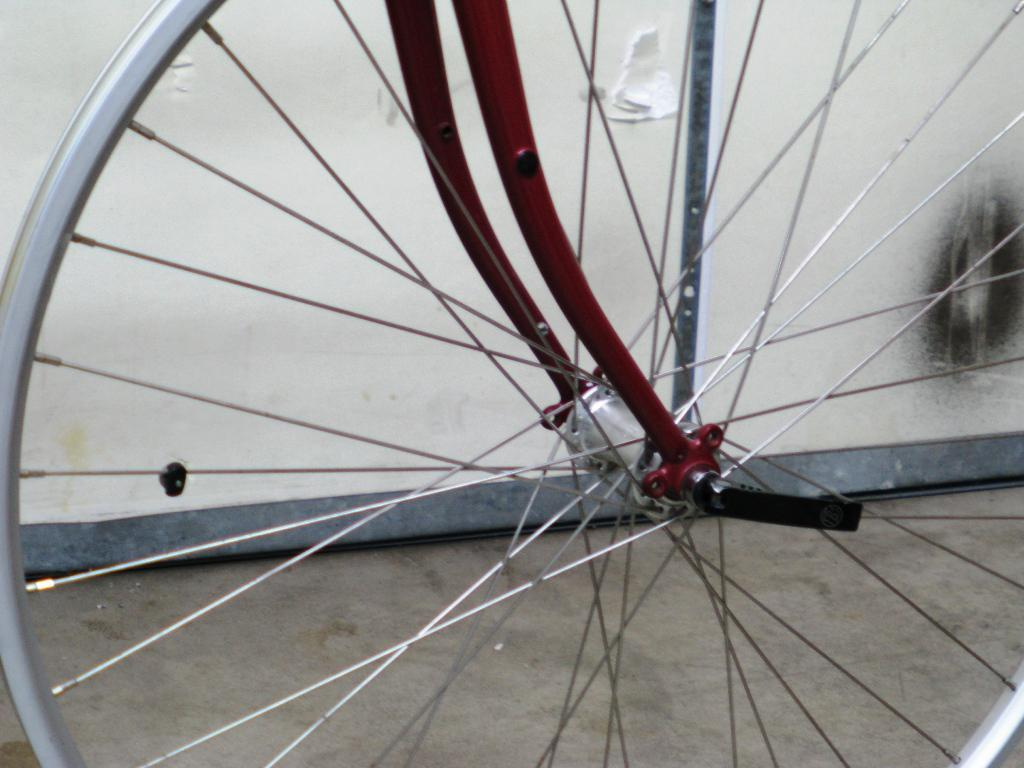What object is visible on the ground in the image? There is a rim of a bicycle on the ground. What can be seen in the background of the image? There is a wall visible in the background of the image. Where is the playground located in the image? There is no playground present in the image. What type of activity is taking place in the image? The image does not depict any specific activity; it only shows a rim of a bicycle on the ground and a wall in the background. 